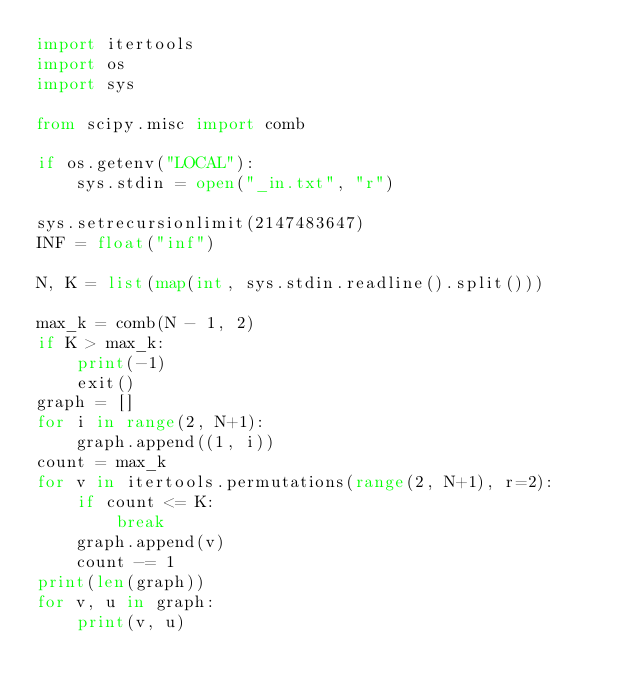Convert code to text. <code><loc_0><loc_0><loc_500><loc_500><_Python_>import itertools
import os
import sys

from scipy.misc import comb

if os.getenv("LOCAL"):
    sys.stdin = open("_in.txt", "r")

sys.setrecursionlimit(2147483647)
INF = float("inf")

N, K = list(map(int, sys.stdin.readline().split()))

max_k = comb(N - 1, 2)
if K > max_k:
    print(-1)
    exit()
graph = []
for i in range(2, N+1):
    graph.append((1, i))
count = max_k
for v in itertools.permutations(range(2, N+1), r=2):
    if count <= K:
        break
    graph.append(v)
    count -= 1
print(len(graph))
for v, u in graph:
    print(v, u)


</code> 